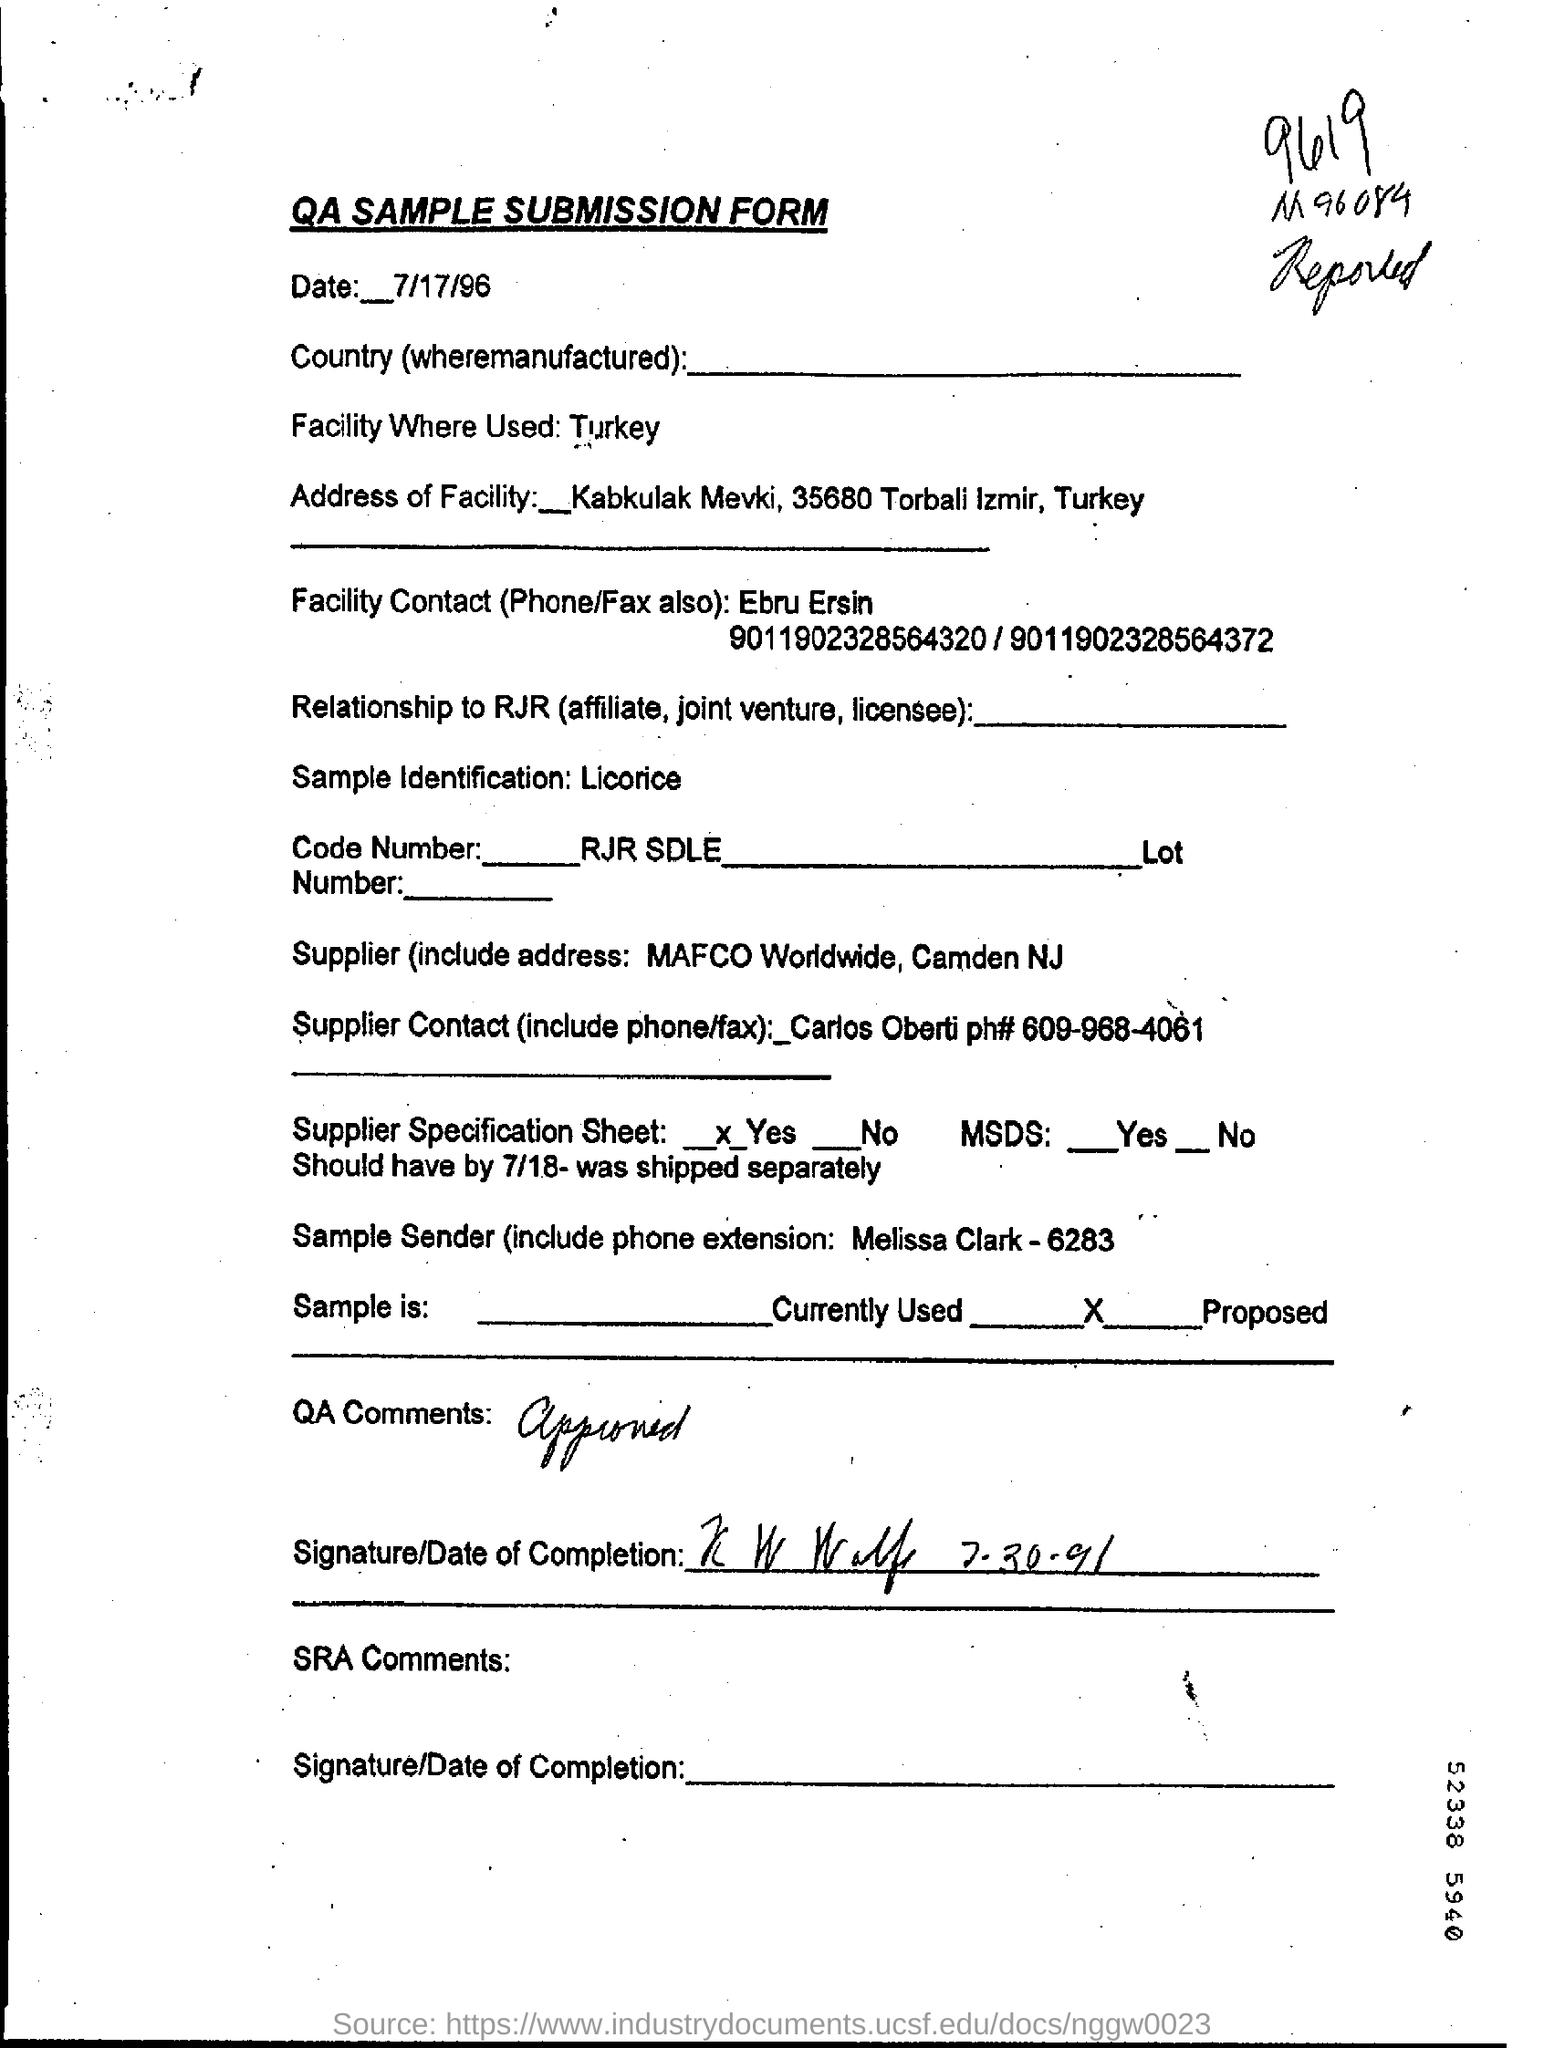Give some essential details in this illustration. The person named Ebru Ersin is the facility contact. The facility in question was used in a country whose name is Turkey. The date in the sample submission form is July 17, 1996. 